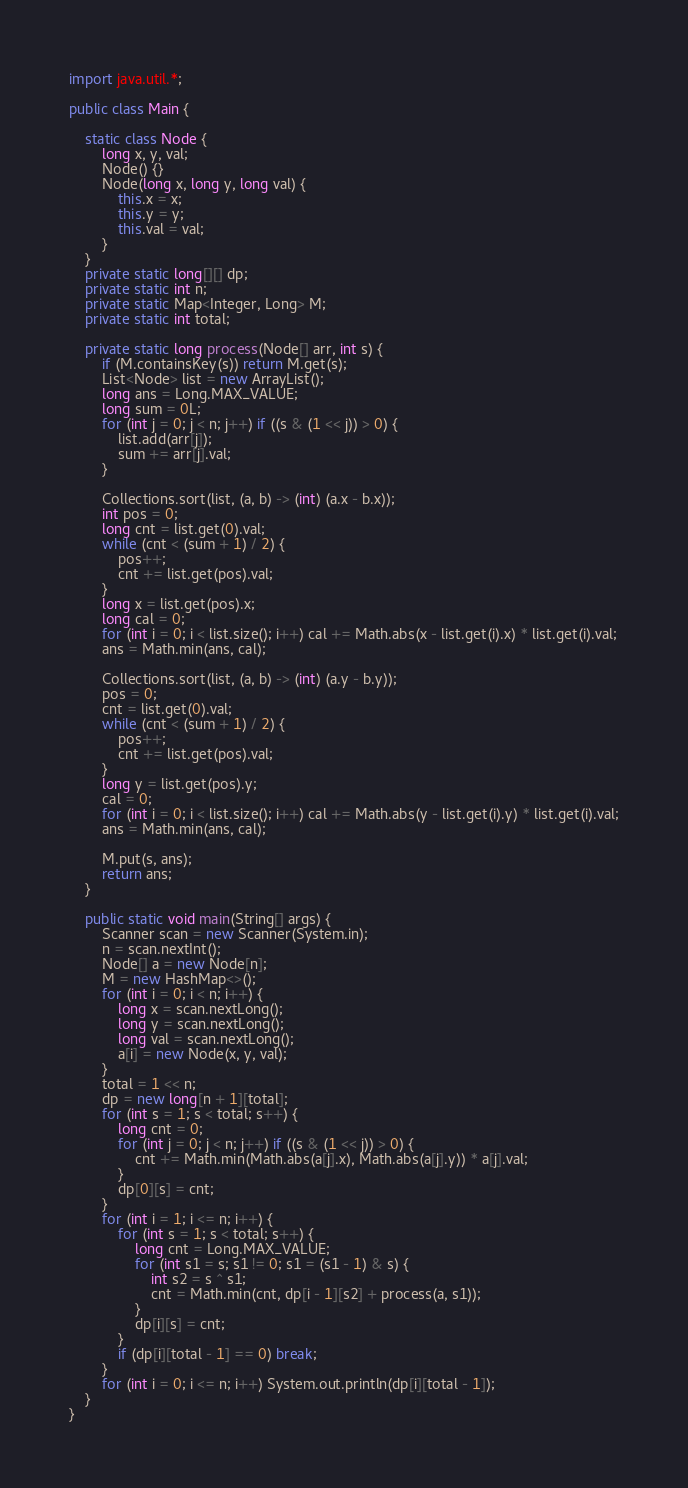Convert code to text. <code><loc_0><loc_0><loc_500><loc_500><_Java_>import java.util.*;

public class Main {

    static class Node {
        long x, y, val;
        Node() {}
        Node(long x, long y, long val) {
            this.x = x;
            this.y = y;
            this.val = val;
        }
    }
    private static long[][] dp;
    private static int n;
    private static Map<Integer, Long> M;
    private static int total;

    private static long process(Node[] arr, int s) {
        if (M.containsKey(s)) return M.get(s);
        List<Node> list = new ArrayList();
        long ans = Long.MAX_VALUE;
        long sum = 0L;
        for (int j = 0; j < n; j++) if ((s & (1 << j)) > 0) {
            list.add(arr[j]);
            sum += arr[j].val;
        }

        Collections.sort(list, (a, b) -> (int) (a.x - b.x));
        int pos = 0;
        long cnt = list.get(0).val;
        while (cnt < (sum + 1) / 2) {
            pos++;
            cnt += list.get(pos).val;
        }
        long x = list.get(pos).x;
        long cal = 0;
        for (int i = 0; i < list.size(); i++) cal += Math.abs(x - list.get(i).x) * list.get(i).val;
        ans = Math.min(ans, cal);

        Collections.sort(list, (a, b) -> (int) (a.y - b.y));
        pos = 0;
        cnt = list.get(0).val;
        while (cnt < (sum + 1) / 2) {
            pos++;
            cnt += list.get(pos).val;
        }
        long y = list.get(pos).y;
        cal = 0;
        for (int i = 0; i < list.size(); i++) cal += Math.abs(y - list.get(i).y) * list.get(i).val;
        ans = Math.min(ans, cal);

        M.put(s, ans);
        return ans;
    }

    public static void main(String[] args) {
        Scanner scan = new Scanner(System.in);
        n = scan.nextInt();
        Node[] a = new Node[n];
        M = new HashMap<>();
        for (int i = 0; i < n; i++) {
            long x = scan.nextLong();
            long y = scan.nextLong();
            long val = scan.nextLong();
            a[i] = new Node(x, y, val);
        }
        total = 1 << n;
        dp = new long[n + 1][total];
        for (int s = 1; s < total; s++) {
            long cnt = 0;
            for (int j = 0; j < n; j++) if ((s & (1 << j)) > 0) {
                cnt += Math.min(Math.abs(a[j].x), Math.abs(a[j].y)) * a[j].val;
            }
            dp[0][s] = cnt;
        }
        for (int i = 1; i <= n; i++) {
            for (int s = 1; s < total; s++) {
                long cnt = Long.MAX_VALUE;
                for (int s1 = s; s1 != 0; s1 = (s1 - 1) & s) {
                    int s2 = s ^ s1;
                    cnt = Math.min(cnt, dp[i - 1][s2] + process(a, s1));
                }
                dp[i][s] = cnt;
            }
            if (dp[i][total - 1] == 0) break;
        }
        for (int i = 0; i <= n; i++) System.out.println(dp[i][total - 1]);
    }
}
</code> 